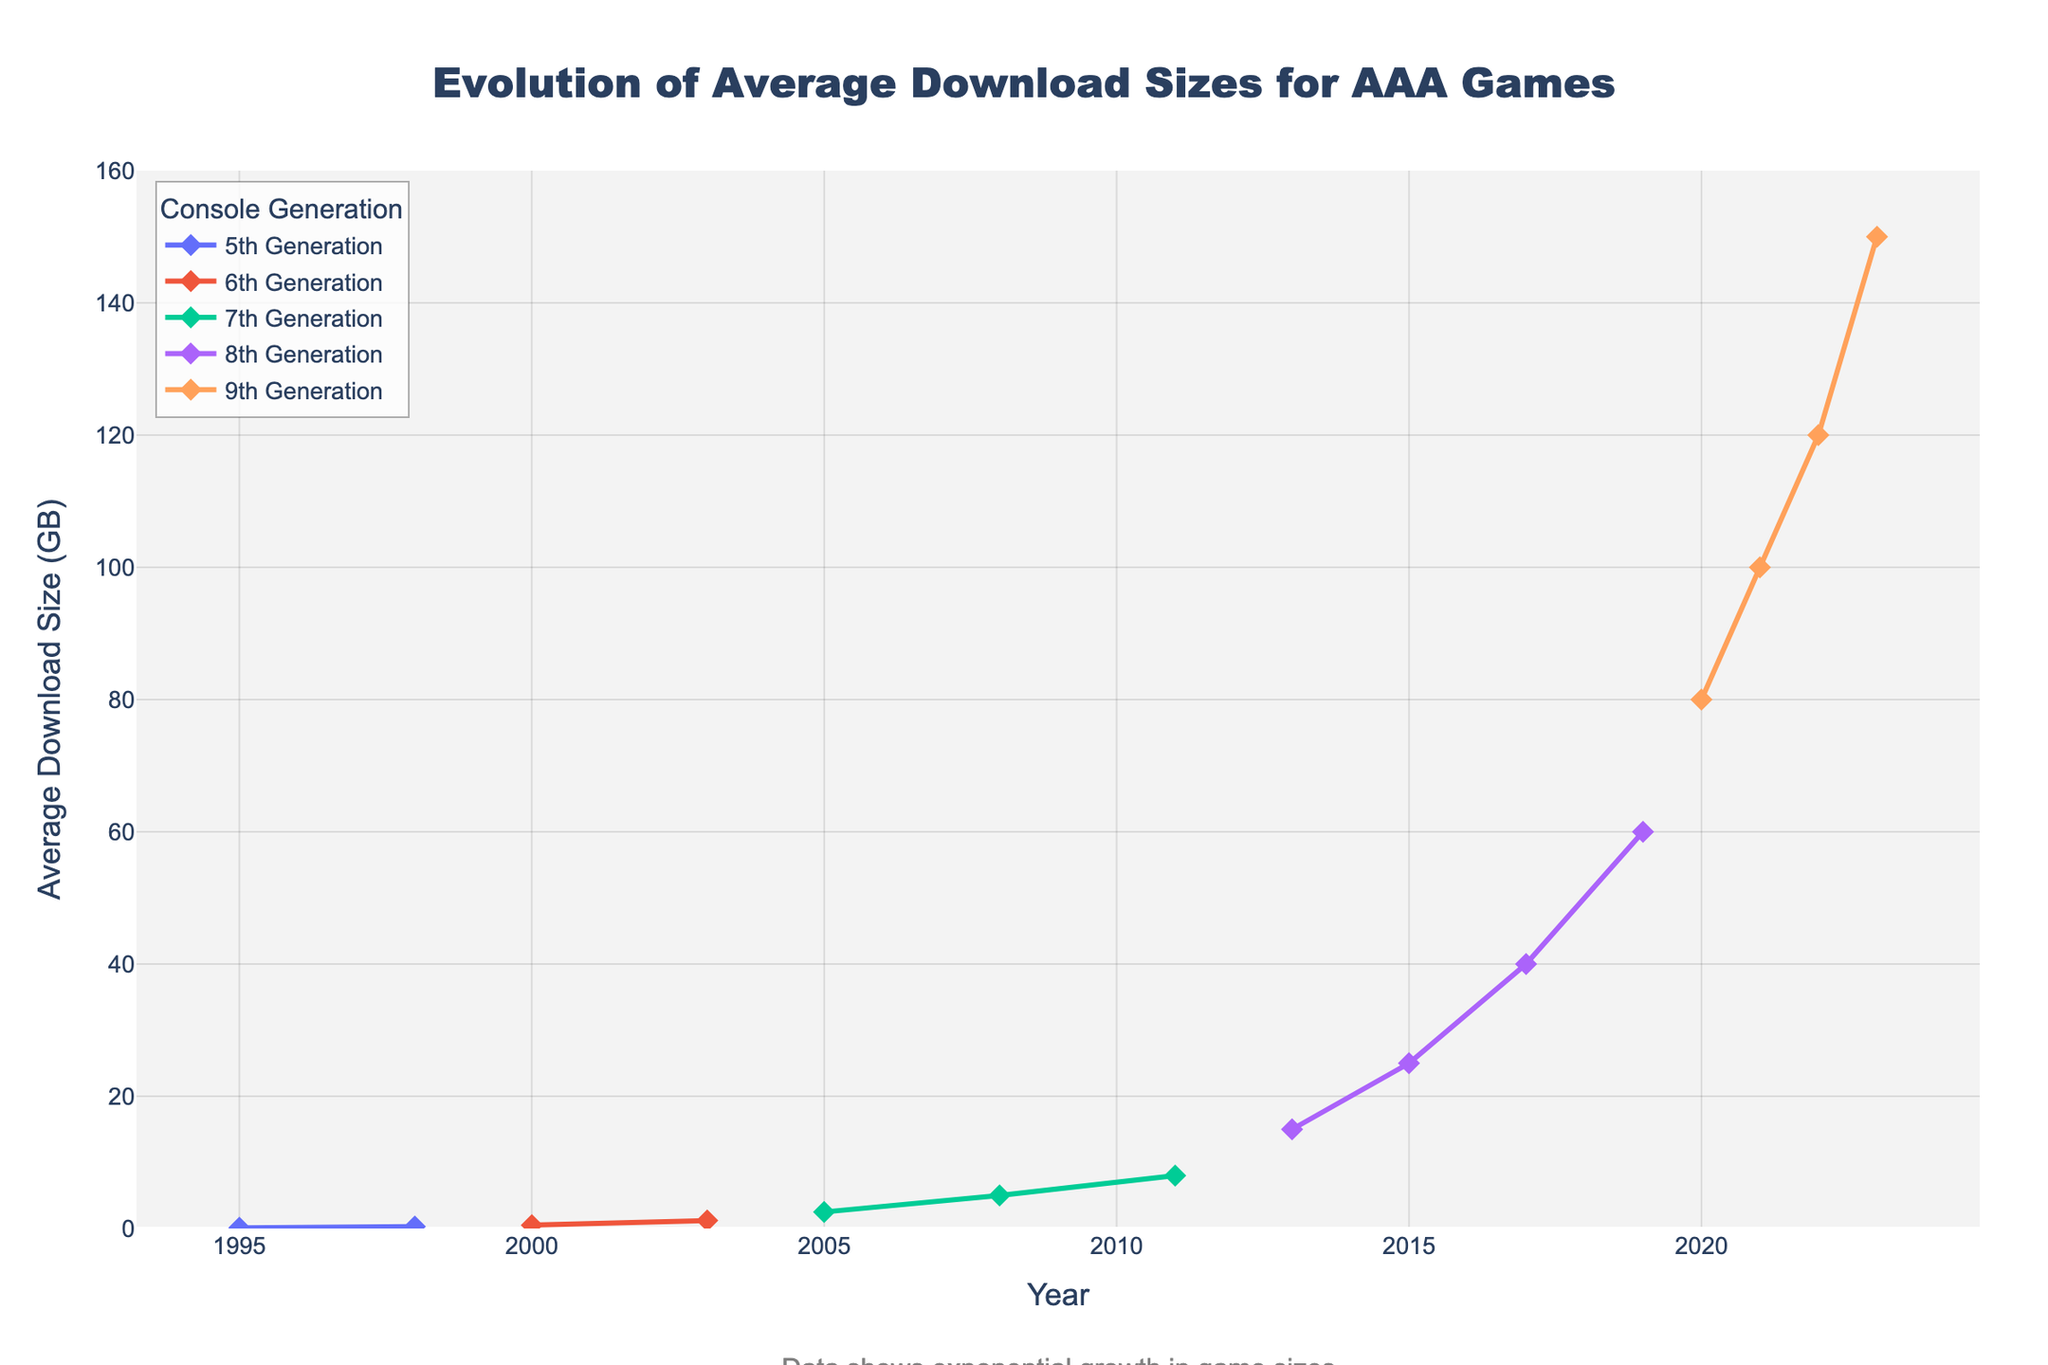What's the average download size for 8th Generation games in 2015 and 2019? In 2015, the average download size for 8th Generation games is 25.0 GB, and in 2019 it is 60.0 GB. To find the average of these two values: (25.0 + 60.0) / 2 = 42.5
Answer: 42.5 Which console generation showed the highest increase in download size in a single year? The largest increase seems to occur within the 9th Generation from 2020 (80.0 GB) to 2021 (100.0 GB), which is an increase of 20.0 GB. Another increase occurs from 6th Generation in 2000 (0.5 GB) to 2003 (1.2 GB) increasing by 0.7 GB. Clearly, 9th Generation shows the largest single-year increase from 80.0 GB to 120.0 GB, which is an increase of 40.0 GB.
Answer: 9th Generation Compare the download sizes in 2013 and 2023. Which year had a larger download size and by how much? In 2013, the download size is 15.0 GB, and in 2023 it is 150.0 GB. To find the difference: 150.0 - 15.0 = 135.0 GB. Therefore, 2023 has a larger download size by 135.0 GB.
Answer: 2023 by 135.0 GB What is the trend in the average download size for AAA games from 1995 to 2023? The trend shows a continuous exponential growth in average download sizes starting from 0.1 GB in 1995 to 150.0 GB in 2023. This means that the sizes have been increasing steadily across all generations, showing an upward trajectory on the chart.
Answer: Continuous exponential growth How many years did it take for the average download size to grow from 1.2 GB to 80.0 GB? Initially, the average download size was 1.2 GB in 2003 (6th Generation). It reaches 80.0 GB in 2020 (9th Generation). The duration between these two years is 2020 - 2003 = 17 years.
Answer: 17 years Is there any generation where the average download size does not increase significantly at any point? The 5th Generation, between 1995 and 1998, shows a relatively modest increase in average download size, from 0.1 GB in 1995 to 0.3 GB in 1998, indicating less significant increases compared to other generations.
Answer: 5th Generation What is the smallest average download size recorded and in which year and console generation did it occur? The smallest average download size recorded is 0.1 GB. This occurred in the 5th Generation in the year 1995.
Answer: 0.1 GB in 1995, 5th Generation 